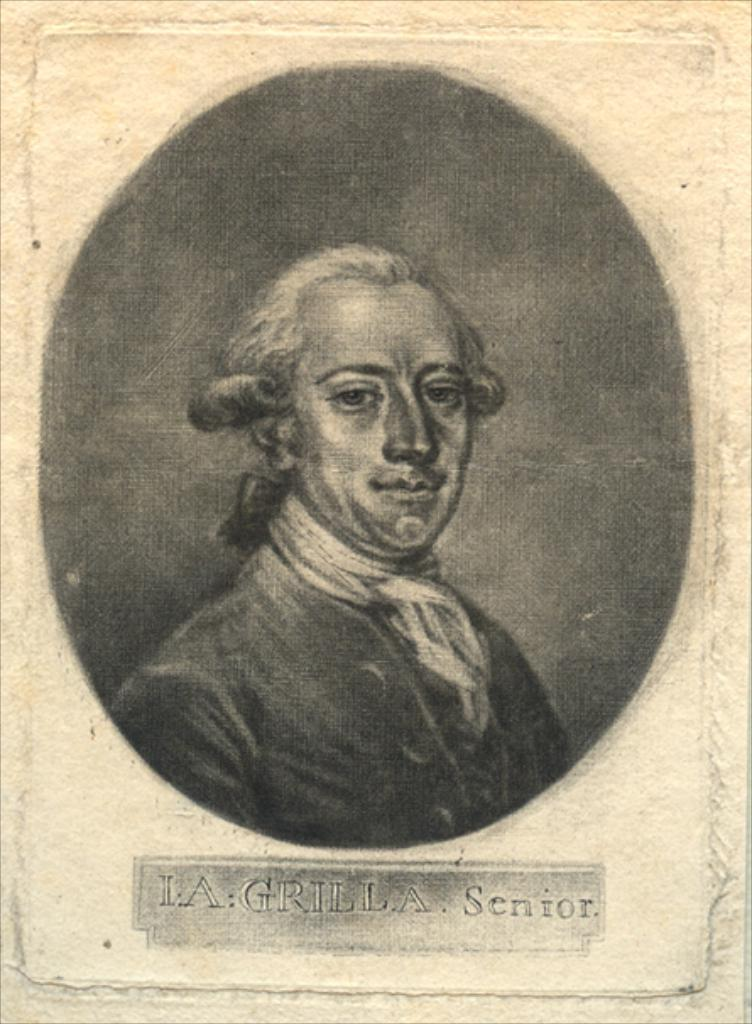What is the main subject of the image? There is a photo of a man in the image. What can be said about the color of the photo? The photo is black and white in color. Are there any additional details on the photo? Yes, there is writing on the photo. What type of furniture is visible in the image? There is no furniture present in the image; it only contains a black and white photo of a man with writing on it. Can you tell me how many rifles are depicted in the image? There are no rifles present in the image. 